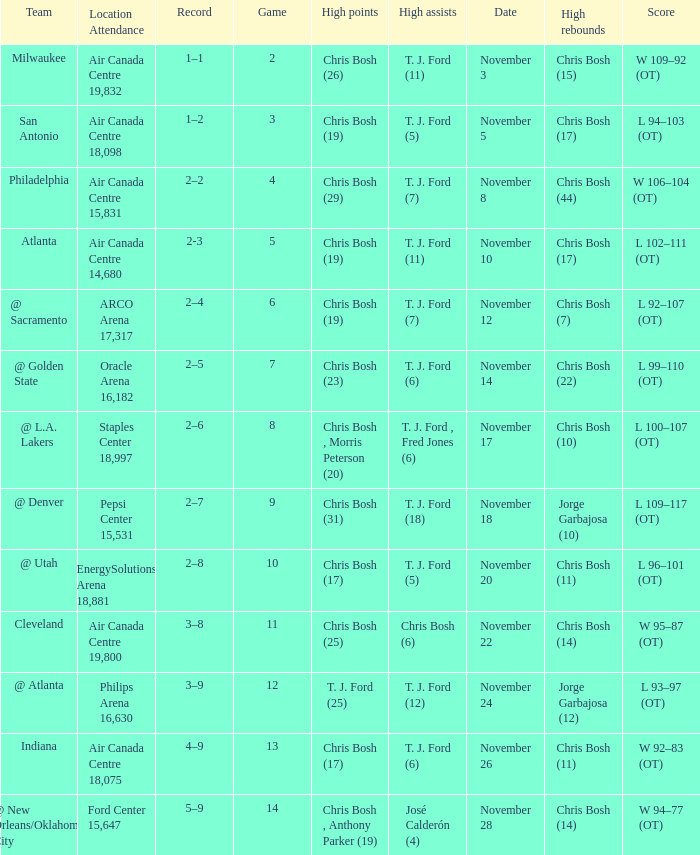Give me the full table as a dictionary. {'header': ['Team', 'Location Attendance', 'Record', 'Game', 'High points', 'High assists', 'Date', 'High rebounds', 'Score'], 'rows': [['Milwaukee', 'Air Canada Centre 19,832', '1–1', '2', 'Chris Bosh (26)', 'T. J. Ford (11)', 'November 3', 'Chris Bosh (15)', 'W 109–92 (OT)'], ['San Antonio', 'Air Canada Centre 18,098', '1–2', '3', 'Chris Bosh (19)', 'T. J. Ford (5)', 'November 5', 'Chris Bosh (17)', 'L 94–103 (OT)'], ['Philadelphia', 'Air Canada Centre 15,831', '2–2', '4', 'Chris Bosh (29)', 'T. J. Ford (7)', 'November 8', 'Chris Bosh (44)', 'W 106–104 (OT)'], ['Atlanta', 'Air Canada Centre 14,680', '2-3', '5', 'Chris Bosh (19)', 'T. J. Ford (11)', 'November 10', 'Chris Bosh (17)', 'L 102–111 (OT)'], ['@ Sacramento', 'ARCO Arena 17,317', '2–4', '6', 'Chris Bosh (19)', 'T. J. Ford (7)', 'November 12', 'Chris Bosh (7)', 'L 92–107 (OT)'], ['@ Golden State', 'Oracle Arena 16,182', '2–5', '7', 'Chris Bosh (23)', 'T. J. Ford (6)', 'November 14', 'Chris Bosh (22)', 'L 99–110 (OT)'], ['@ L.A. Lakers', 'Staples Center 18,997', '2–6', '8', 'Chris Bosh , Morris Peterson (20)', 'T. J. Ford , Fred Jones (6)', 'November 17', 'Chris Bosh (10)', 'L 100–107 (OT)'], ['@ Denver', 'Pepsi Center 15,531', '2–7', '9', 'Chris Bosh (31)', 'T. J. Ford (18)', 'November 18', 'Jorge Garbajosa (10)', 'L 109–117 (OT)'], ['@ Utah', 'EnergySolutions Arena 18,881', '2–8', '10', 'Chris Bosh (17)', 'T. J. Ford (5)', 'November 20', 'Chris Bosh (11)', 'L 96–101 (OT)'], ['Cleveland', 'Air Canada Centre 19,800', '3–8', '11', 'Chris Bosh (25)', 'Chris Bosh (6)', 'November 22', 'Chris Bosh (14)', 'W 95–87 (OT)'], ['@ Atlanta', 'Philips Arena 16,630', '3–9', '12', 'T. J. Ford (25)', 'T. J. Ford (12)', 'November 24', 'Jorge Garbajosa (12)', 'L 93–97 (OT)'], ['Indiana', 'Air Canada Centre 18,075', '4–9', '13', 'Chris Bosh (17)', 'T. J. Ford (6)', 'November 26', 'Chris Bosh (11)', 'W 92–83 (OT)'], ['@ New Orleans/Oklahoma City', 'Ford Center 15,647', '5–9', '14', 'Chris Bosh , Anthony Parker (19)', 'José Calderón (4)', 'November 28', 'Chris Bosh (14)', 'W 94–77 (OT)']]} Where was the game on November 20? EnergySolutions Arena 18,881. 